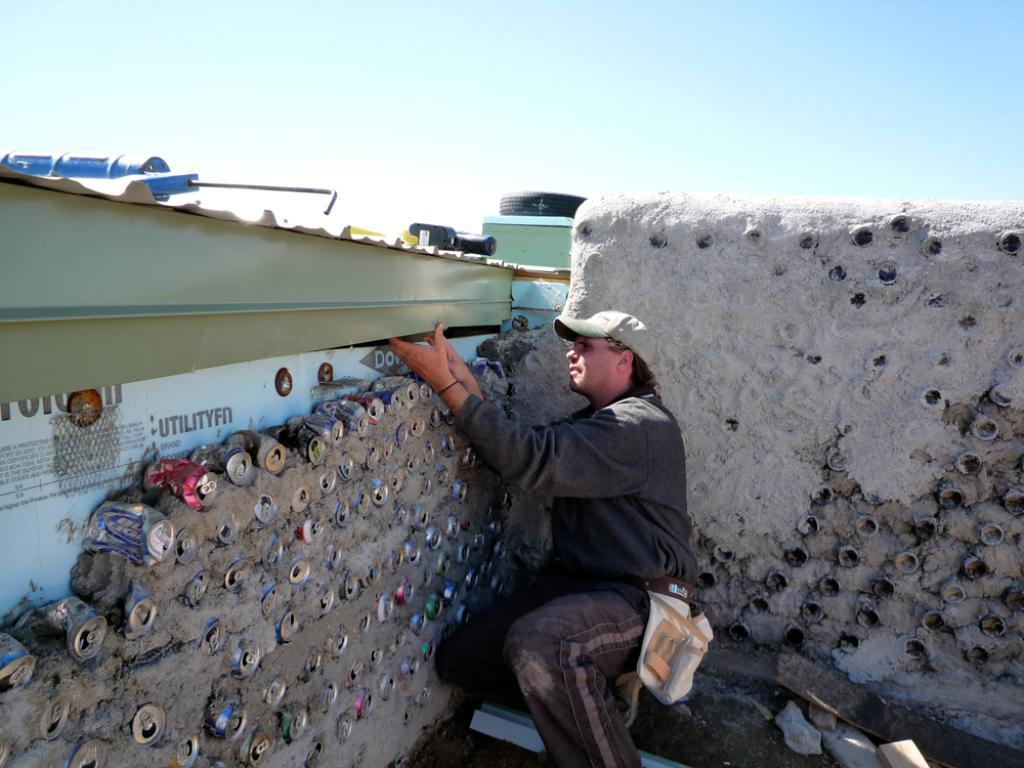<image>
Relay a brief, clear account of the picture shown. Several cans of beer and soda are being used as building materials by a man in a black shirt. 